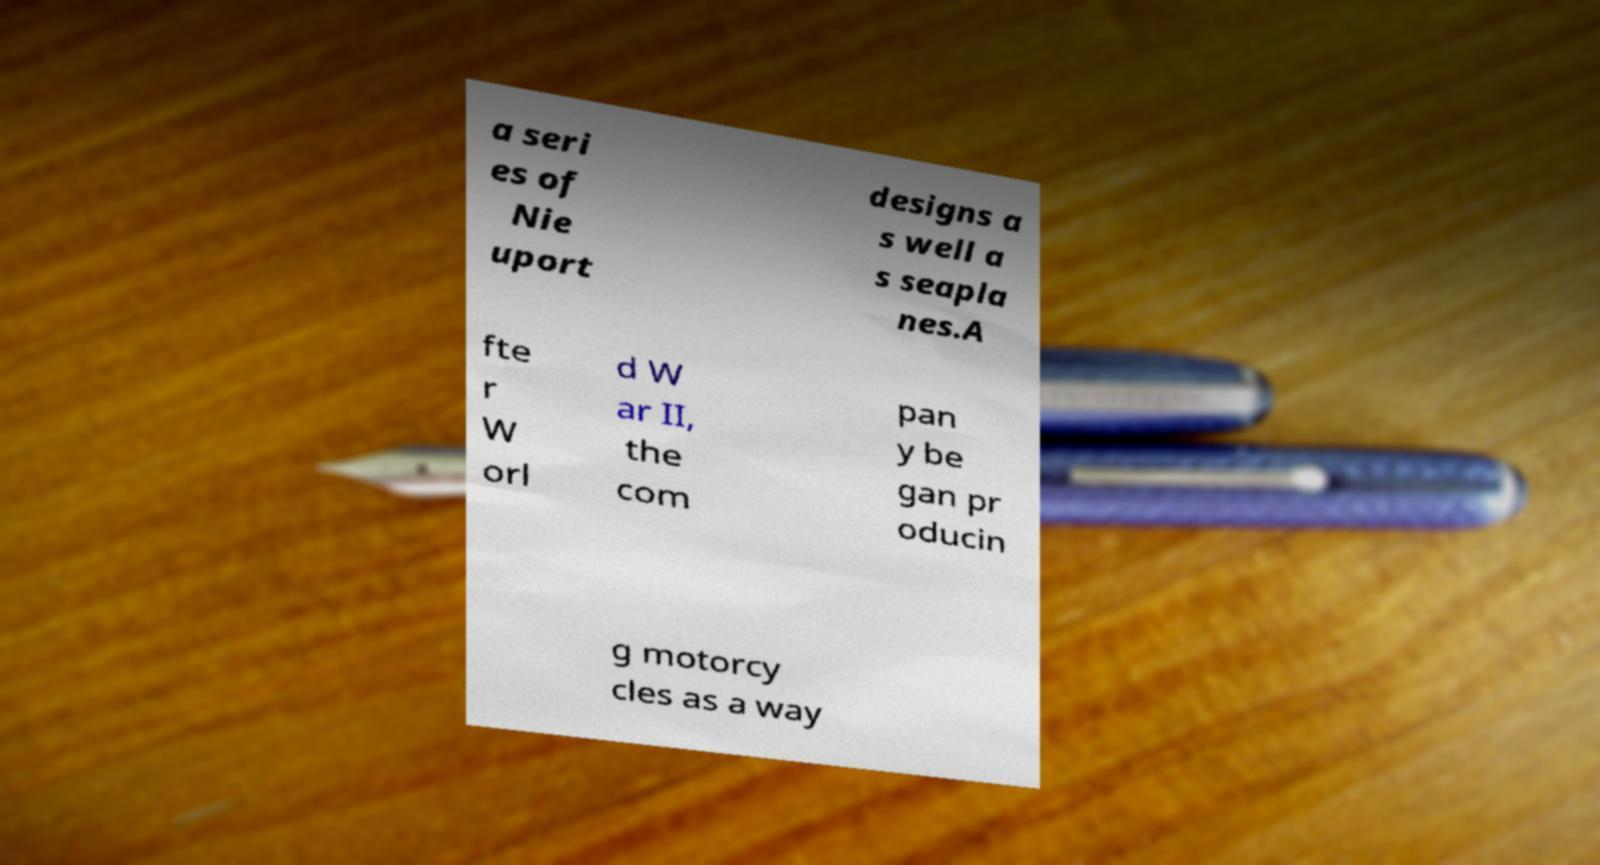For documentation purposes, I need the text within this image transcribed. Could you provide that? a seri es of Nie uport designs a s well a s seapla nes.A fte r W orl d W ar II, the com pan y be gan pr oducin g motorcy cles as a way 